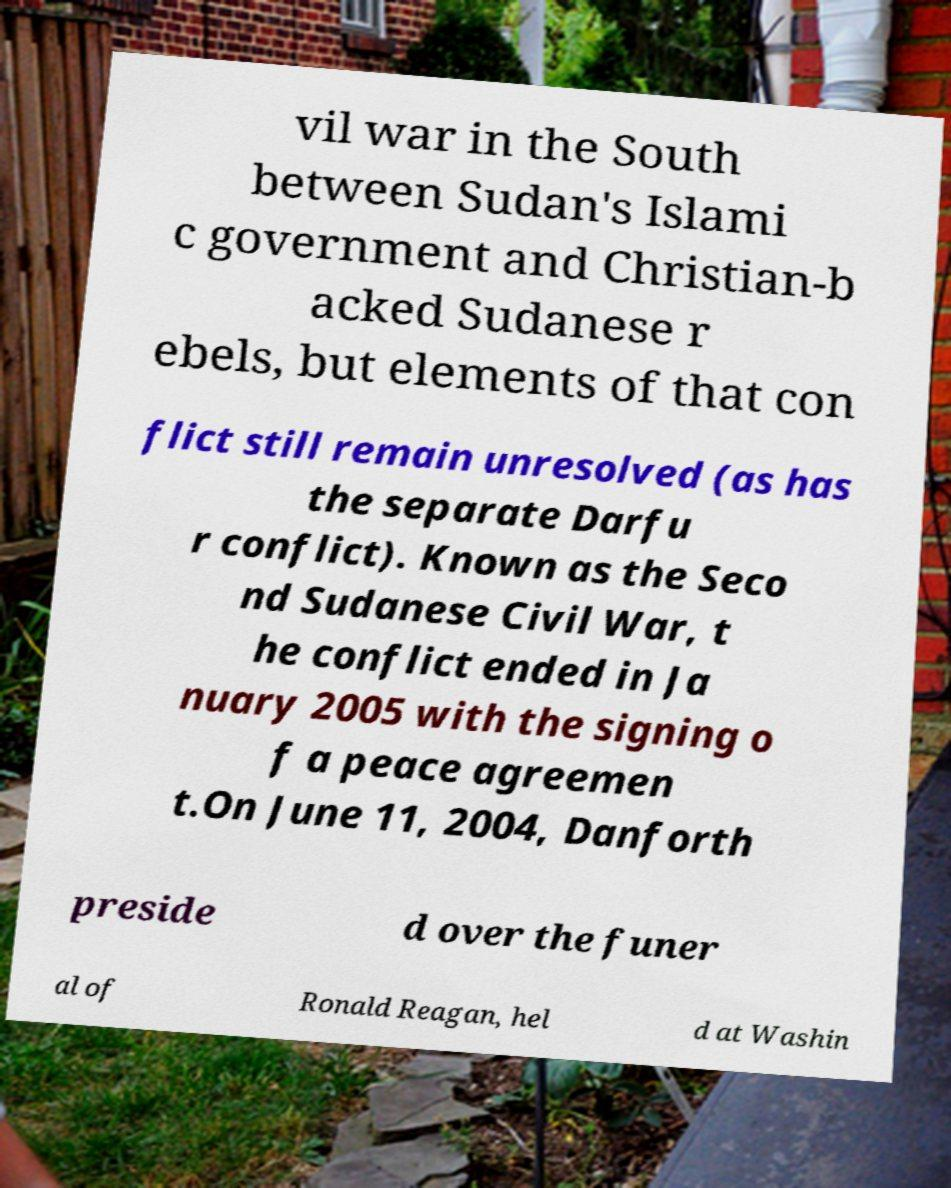For documentation purposes, I need the text within this image transcribed. Could you provide that? vil war in the South between Sudan's Islami c government and Christian-b acked Sudanese r ebels, but elements of that con flict still remain unresolved (as has the separate Darfu r conflict). Known as the Seco nd Sudanese Civil War, t he conflict ended in Ja nuary 2005 with the signing o f a peace agreemen t.On June 11, 2004, Danforth preside d over the funer al of Ronald Reagan, hel d at Washin 